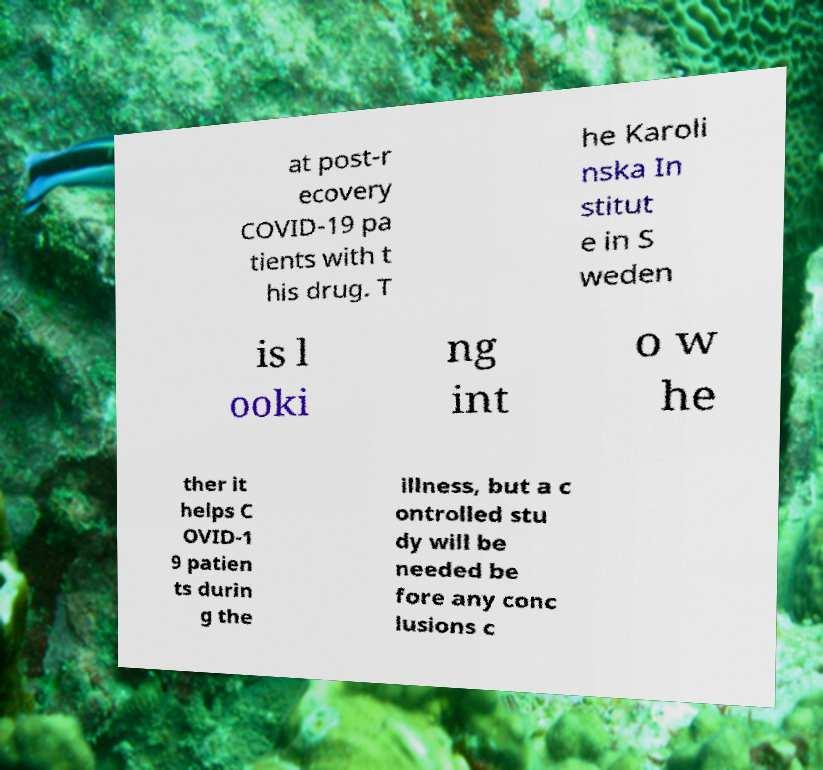Can you accurately transcribe the text from the provided image for me? at post-r ecovery COVID-19 pa tients with t his drug. T he Karoli nska In stitut e in S weden is l ooki ng int o w he ther it helps C OVID-1 9 patien ts durin g the illness, but a c ontrolled stu dy will be needed be fore any conc lusions c 